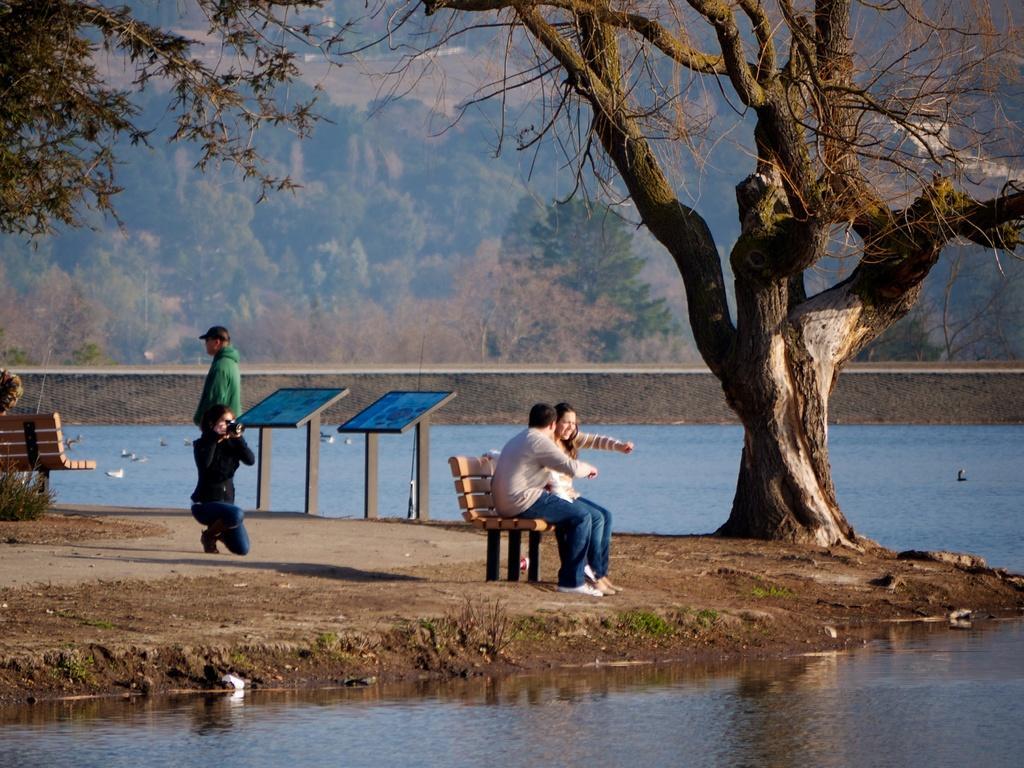Can you describe this image briefly? In this image we can see a couple sitting on bench, we can see a woman wearing black color dress holding camera in her hands, we can see a person wearing green color dress and cap standing and in the background of the image we can see water, there are some trees. 